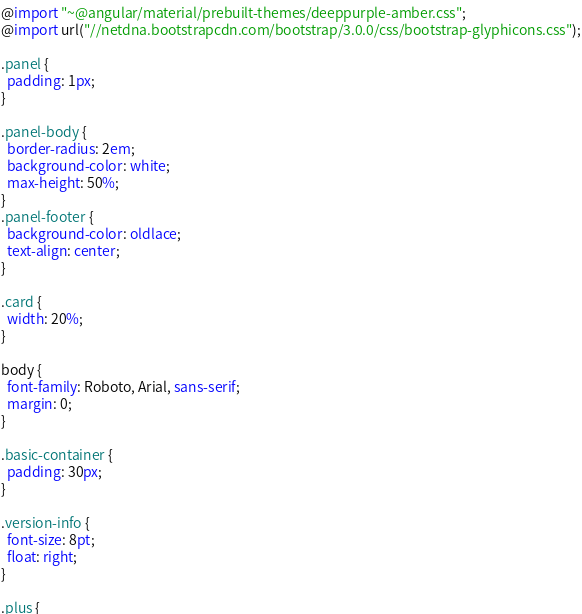<code> <loc_0><loc_0><loc_500><loc_500><_CSS_>@import "~@angular/material/prebuilt-themes/deeppurple-amber.css";
@import url("//netdna.bootstrapcdn.com/bootstrap/3.0.0/css/bootstrap-glyphicons.css");

.panel {
  padding: 1px;
}

.panel-body {
  border-radius: 2em;
  background-color: white;
  max-height: 50%;
}
.panel-footer {
  background-color: oldlace;
  text-align: center;
}

.card {
  width: 20%;
}

body {
  font-family: Roboto, Arial, sans-serif;
  margin: 0;
}

.basic-container {
  padding: 30px;
}

.version-info {
  font-size: 8pt;
  float: right;
}

.plus {</code> 